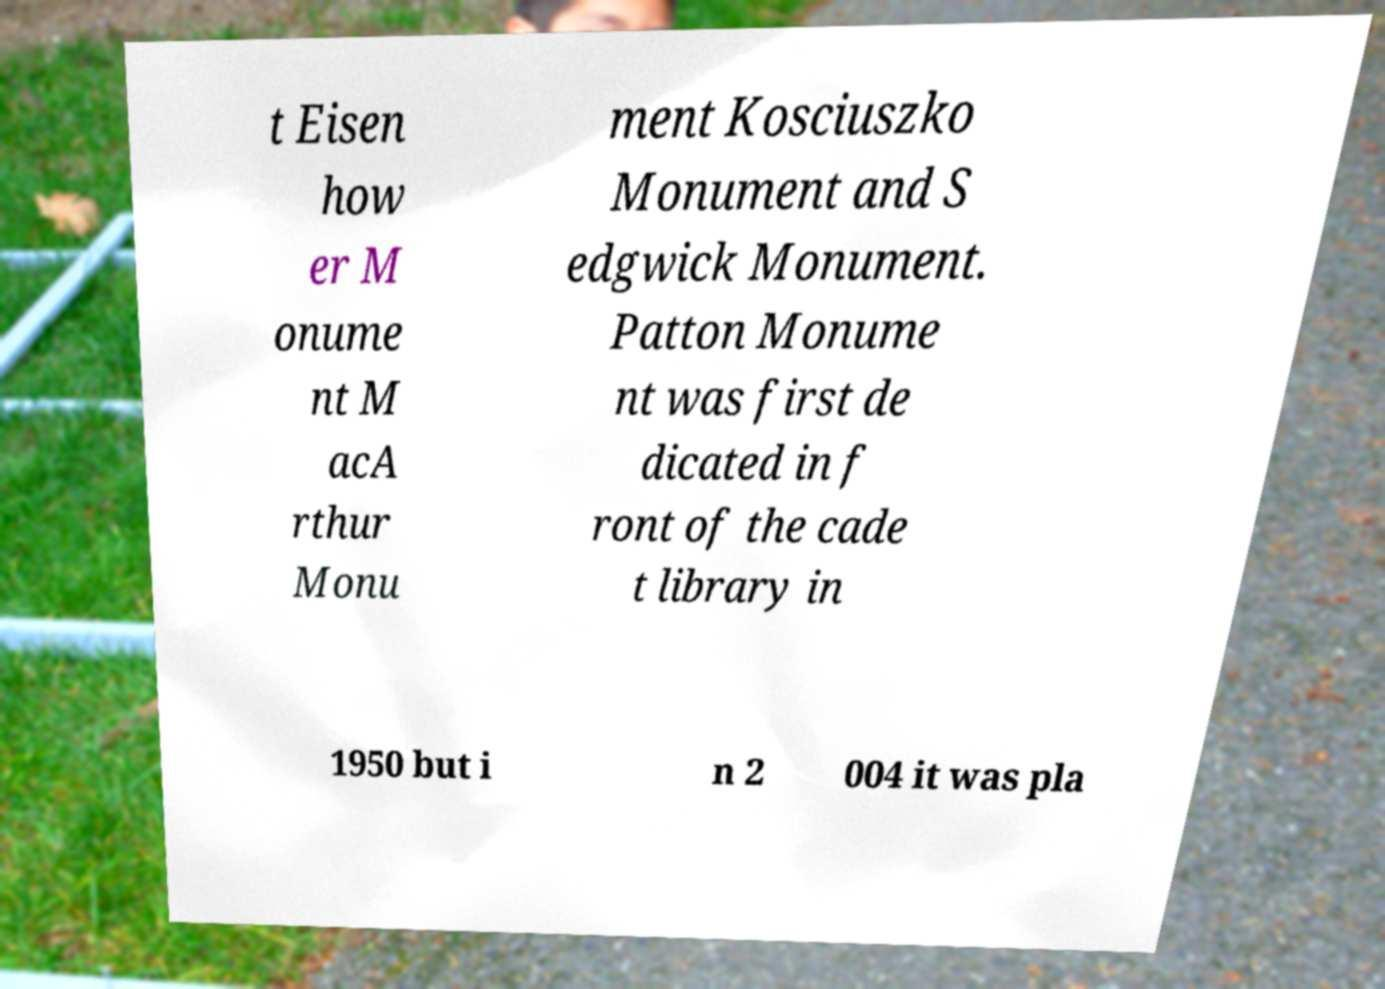What messages or text are displayed in this image? I need them in a readable, typed format. t Eisen how er M onume nt M acA rthur Monu ment Kosciuszko Monument and S edgwick Monument. Patton Monume nt was first de dicated in f ront of the cade t library in 1950 but i n 2 004 it was pla 